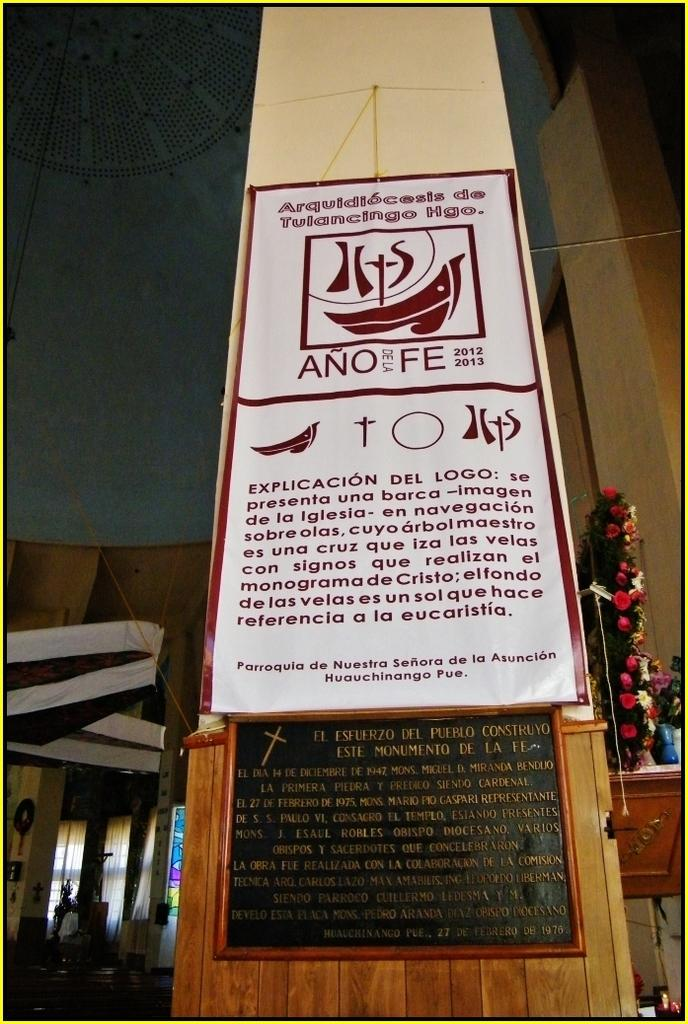What is hanging on the wall in the image? There is a banner on the wall in the image. What piece of furniture is present in the image? There is a table in the image. What decorative item can be seen on the table? There is a flower bouquet on the table. What is placed on the table along with the flower bouquet? There is paper on the table. What else can be found on the table besides the flower bouquet and paper? A: There are objects on the table. Are there any objects located near the table? Yes, there are objects at the side of the table. What type of border is depicted in the scene in the image? There is no specific border depicted in the scene in the image; it features a wall with a banner, a table, and various objects. What color is the sock on the table in the image? There is no sock present on the table or in the image. 